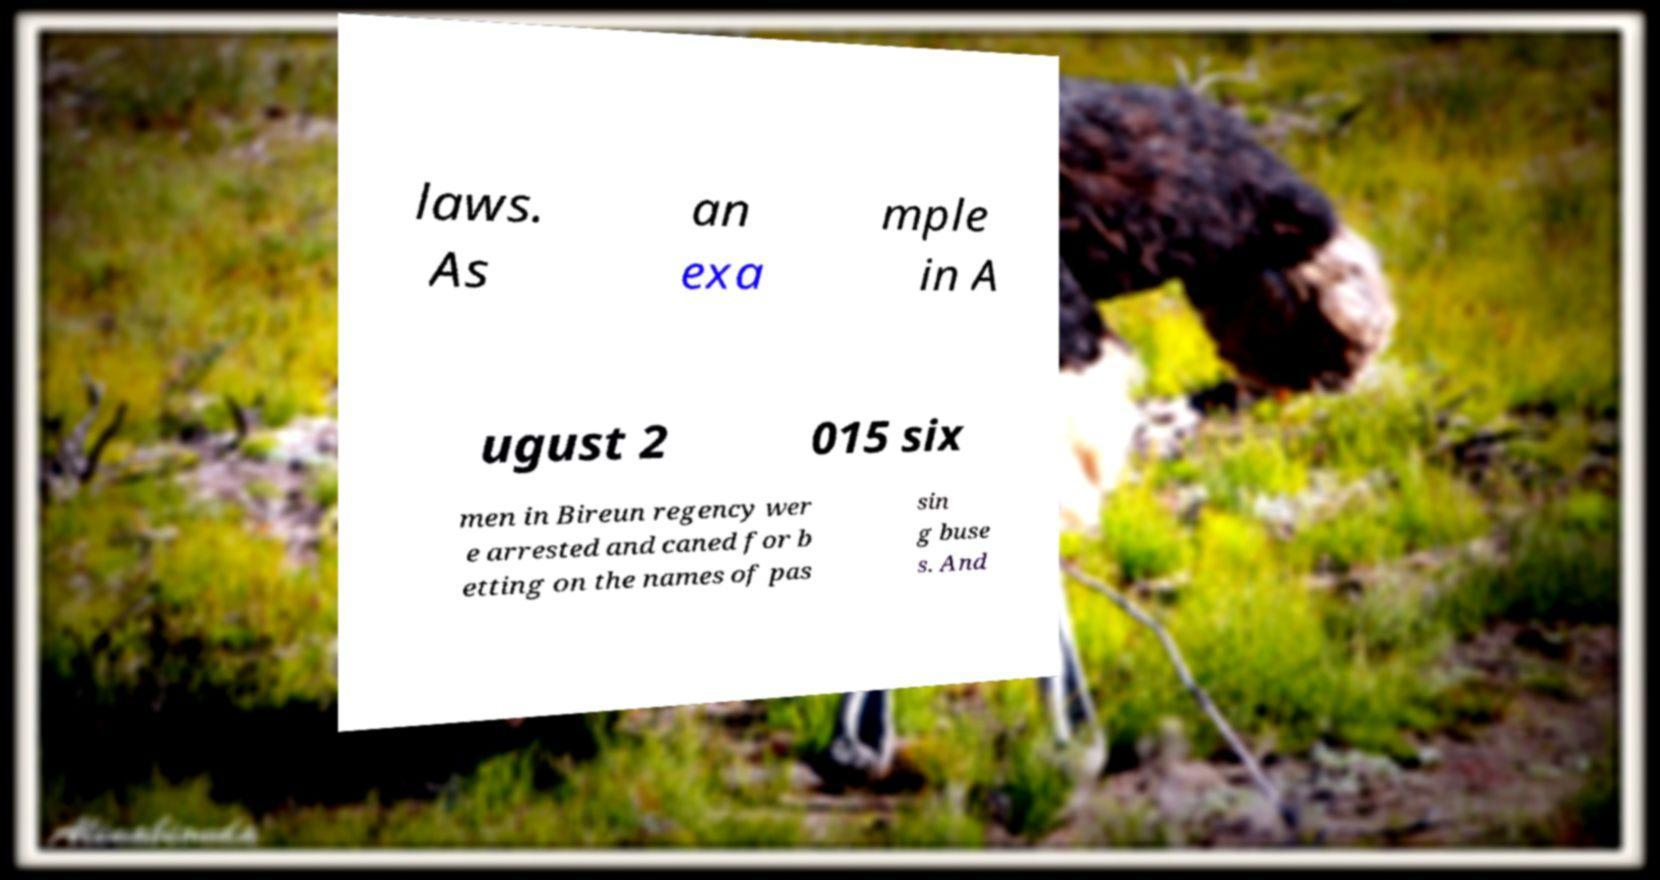Can you accurately transcribe the text from the provided image for me? laws. As an exa mple in A ugust 2 015 six men in Bireun regency wer e arrested and caned for b etting on the names of pas sin g buse s. And 